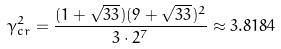<formula> <loc_0><loc_0><loc_500><loc_500>\gamma _ { c r } ^ { 2 } = \frac { ( 1 + \sqrt { 3 3 } ) ( 9 + \sqrt { 3 3 } ) ^ { 2 } } { 3 \cdot 2 ^ { 7 } } \approx 3 . 8 1 8 4</formula> 